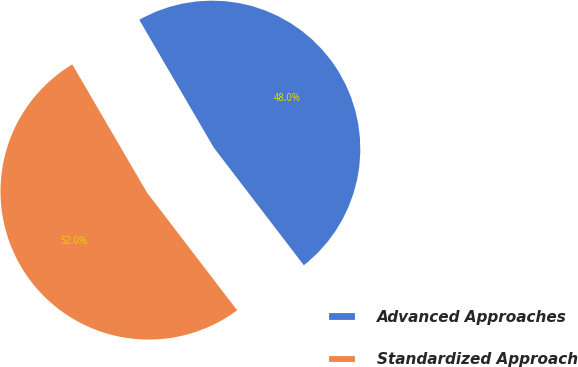<chart> <loc_0><loc_0><loc_500><loc_500><pie_chart><fcel>Advanced Approaches<fcel>Standardized Approach<nl><fcel>48.0%<fcel>52.0%<nl></chart> 